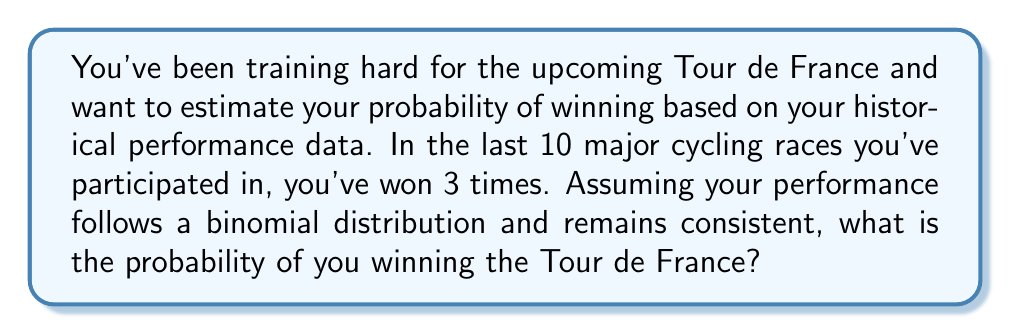Solve this math problem. To solve this problem, we'll use the concept of a binomial distribution, which is appropriate for modeling the number of successes in a fixed number of independent trials.

Given:
- You've participated in 10 major races
- You've won 3 times out of these 10 races

Step 1: Calculate the probability of success (winning) based on historical data.
$p = \frac{\text{number of wins}}{\text{total number of races}} = \frac{3}{10} = 0.3$

Step 2: Use the binomial probability formula to calculate the probability of winning the Tour de France.
The binomial probability formula for a single success is:

$P(X=1) = \binom{n}{k} p^k (1-p)^{n-k}$

Where:
$n = 1$ (we're considering just the Tour de France)
$k = 1$ (we want the probability of winning, which is one success)
$p = 0.3$ (probability of success calculated in Step 1)

Substituting these values:

$P(X=1) = \binom{1}{1} (0.3)^1 (1-0.3)^{1-1}$

$P(X=1) = 1 \cdot 0.3 \cdot 1 = 0.3$

Therefore, based on your historical performance, the probability of winning the Tour de France is 0.3 or 30%.
Answer: 0.3 or 30% 